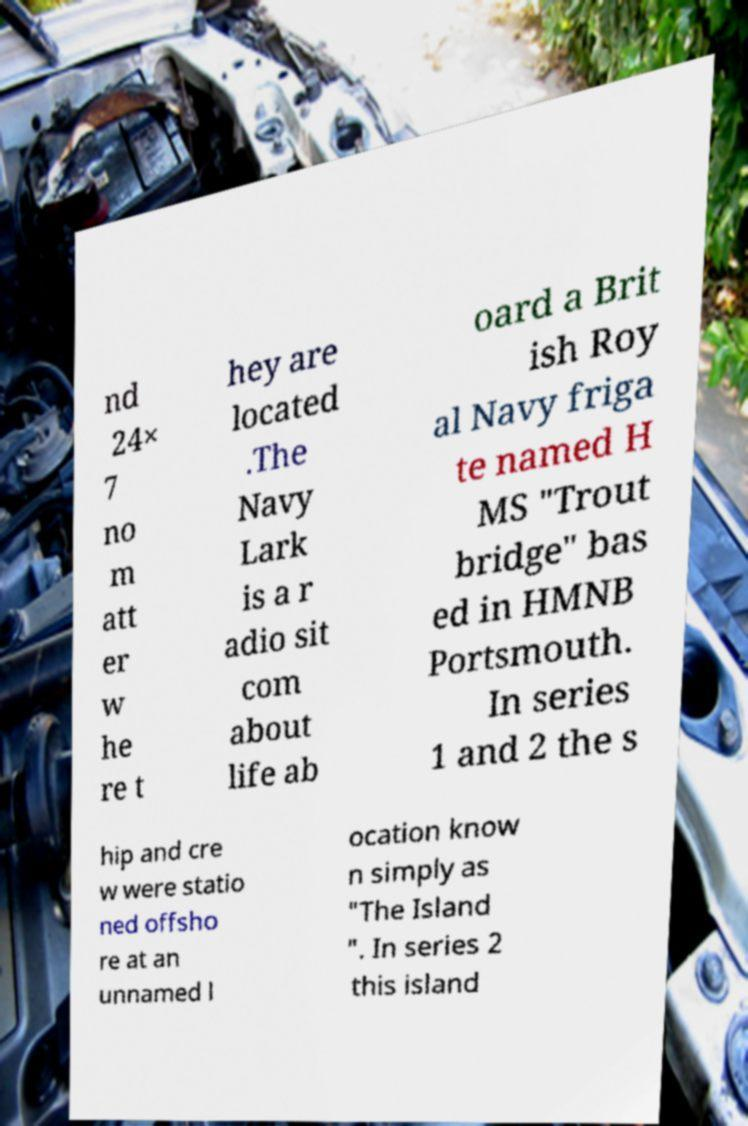What messages or text are displayed in this image? I need them in a readable, typed format. nd 24× 7 no m att er w he re t hey are located .The Navy Lark is a r adio sit com about life ab oard a Brit ish Roy al Navy friga te named H MS "Trout bridge" bas ed in HMNB Portsmouth. In series 1 and 2 the s hip and cre w were statio ned offsho re at an unnamed l ocation know n simply as "The Island ". In series 2 this island 